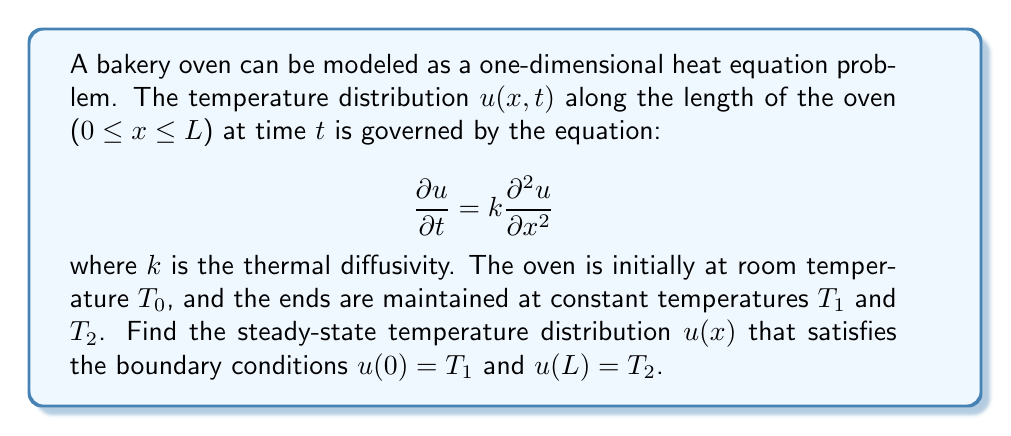Show me your answer to this math problem. To solve this problem, we'll follow these steps:

1) For the steady-state solution, $\frac{\partial u}{\partial t} = 0$, so our equation becomes:

   $$k\frac{d^2u}{dx^2} = 0$$

2) Integrating twice with respect to x:

   $$\frac{du}{dx} = C_1$$
   $$u(x) = C_1x + C_2$$

3) Now we apply the boundary conditions:

   At $x = 0$: $u(0) = T_1 = C_2$
   At $x = L$: $u(L) = T_2 = C_1L + C_2$

4) From these conditions:

   $C_2 = T_1$
   $C_1 = \frac{T_2 - T_1}{L}$

5) Substituting back into our solution:

   $$u(x) = \frac{T_2 - T_1}{L}x + T_1$$

This linear function represents the steady-state temperature distribution along the length of the oven. It's crucial for a food safety inspector to understand this distribution to ensure even baking and food safety.
Answer: $u(x) = \frac{T_2 - T_1}{L}x + T_1$ 